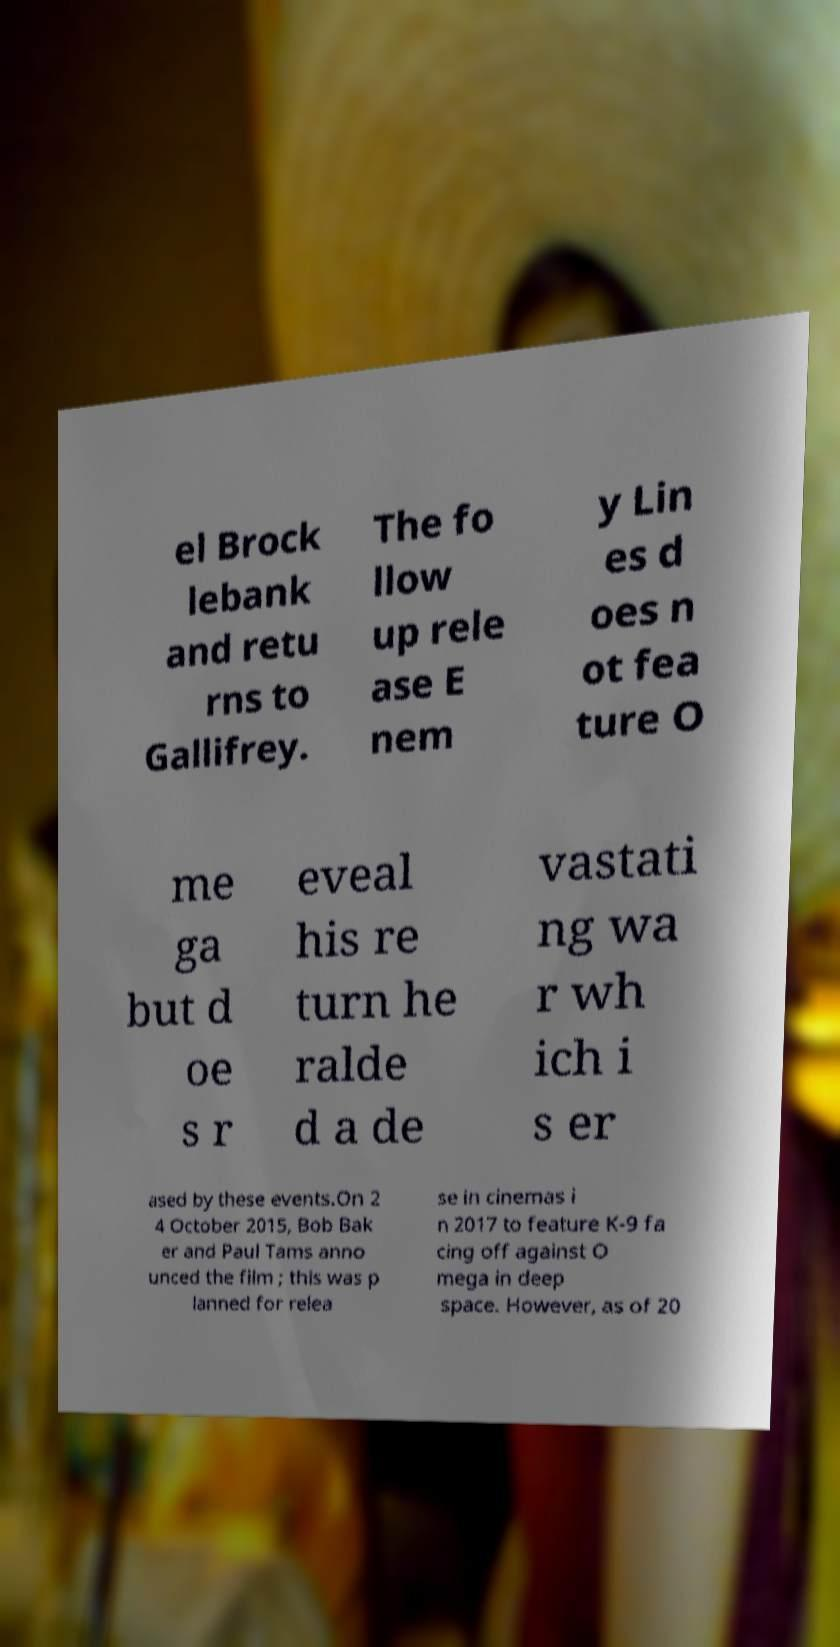There's text embedded in this image that I need extracted. Can you transcribe it verbatim? el Brock lebank and retu rns to Gallifrey. The fo llow up rele ase E nem y Lin es d oes n ot fea ture O me ga but d oe s r eveal his re turn he ralde d a de vastati ng wa r wh ich i s er ased by these events.On 2 4 October 2015, Bob Bak er and Paul Tams anno unced the film ; this was p lanned for relea se in cinemas i n 2017 to feature K-9 fa cing off against O mega in deep space. However, as of 20 